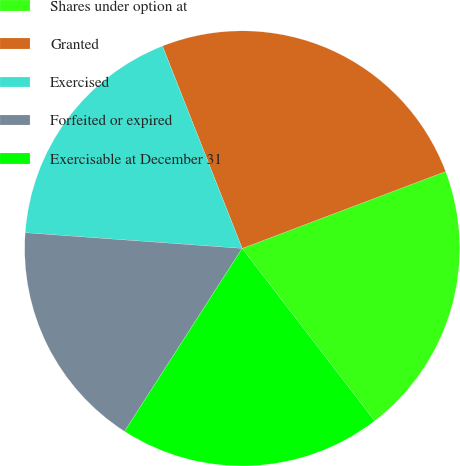<chart> <loc_0><loc_0><loc_500><loc_500><pie_chart><fcel>Shares under option at<fcel>Granted<fcel>Exercised<fcel>Forfeited or expired<fcel>Exercisable at December 31<nl><fcel>20.33%<fcel>25.22%<fcel>17.88%<fcel>17.06%<fcel>19.52%<nl></chart> 